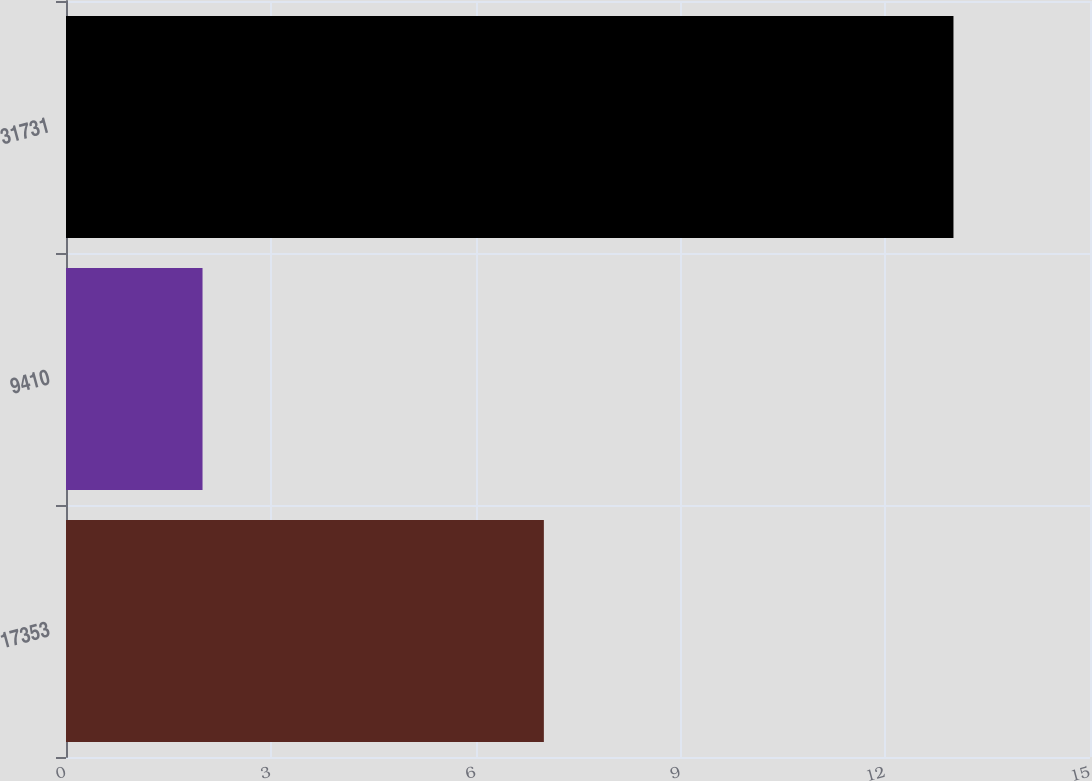<chart> <loc_0><loc_0><loc_500><loc_500><bar_chart><fcel>17353<fcel>9410<fcel>31731<nl><fcel>7<fcel>2<fcel>13<nl></chart> 